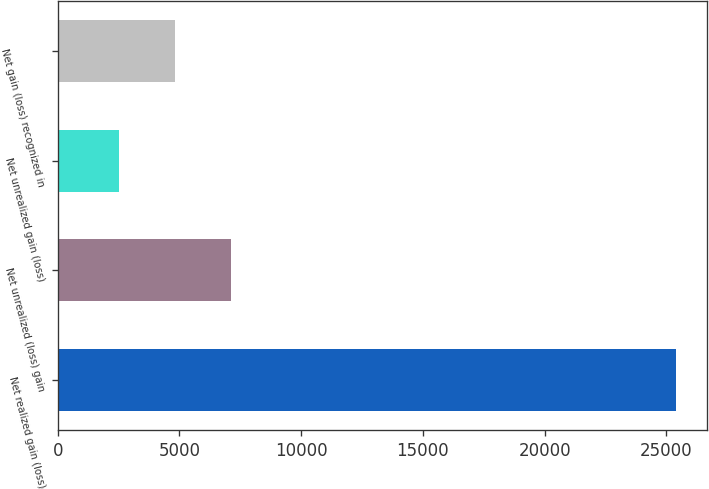<chart> <loc_0><loc_0><loc_500><loc_500><bar_chart><fcel>Net realized gain (loss)<fcel>Net unrealized (loss) gain<fcel>Net unrealized gain (loss)<fcel>Net gain (loss) recognized in<nl><fcel>25384<fcel>7104.8<fcel>2535<fcel>4819.9<nl></chart> 